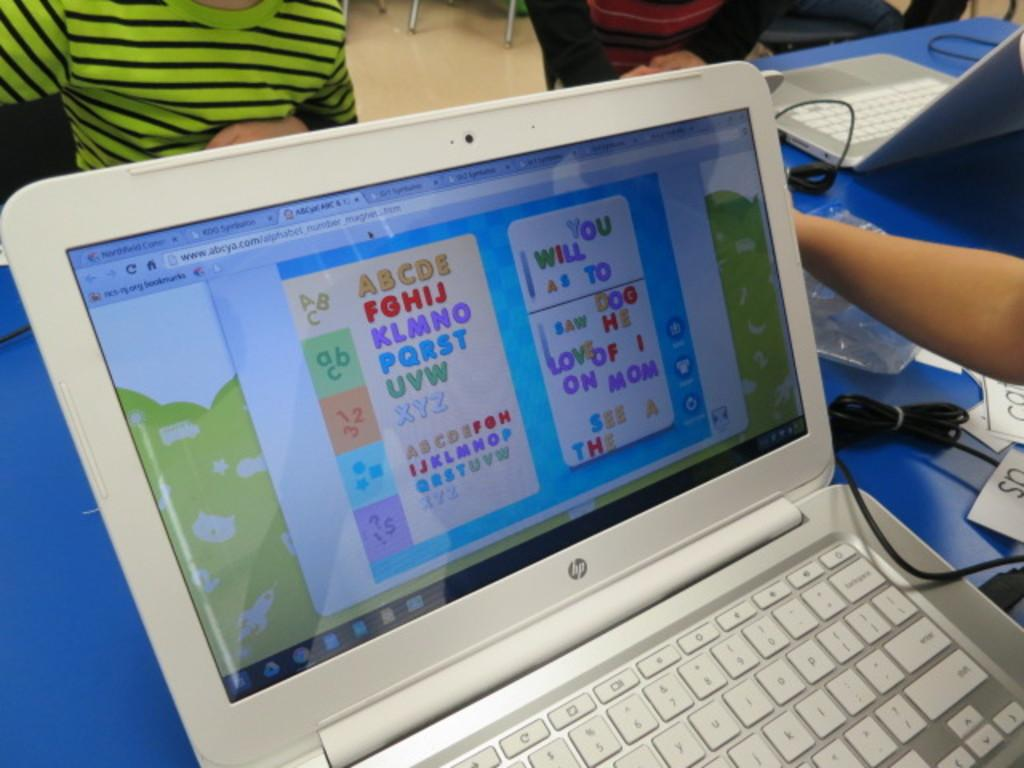<image>
Describe the image concisely. Person using a white HP laptop with the alphabets on it. 